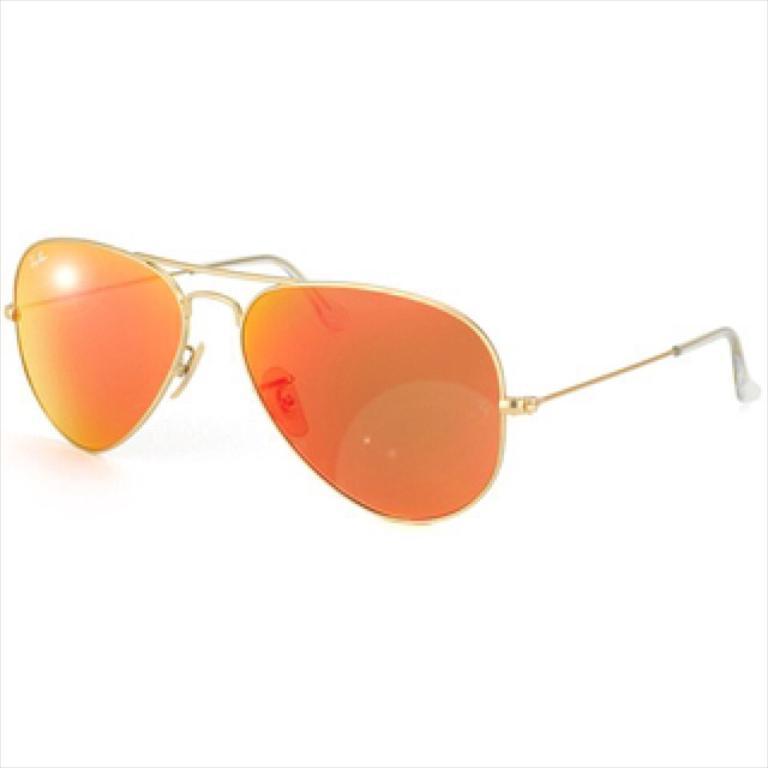Could you give a brief overview of what you see in this image? In this image there is sun glasses at the middle of the image. Background is in white color. 